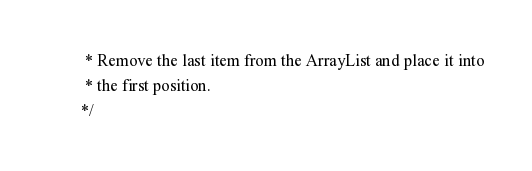Convert code to text. <code><loc_0><loc_0><loc_500><loc_500><_Java_>		 * Remove the last item from the ArrayList and place it into
		 * the first position. 
		*/</code> 